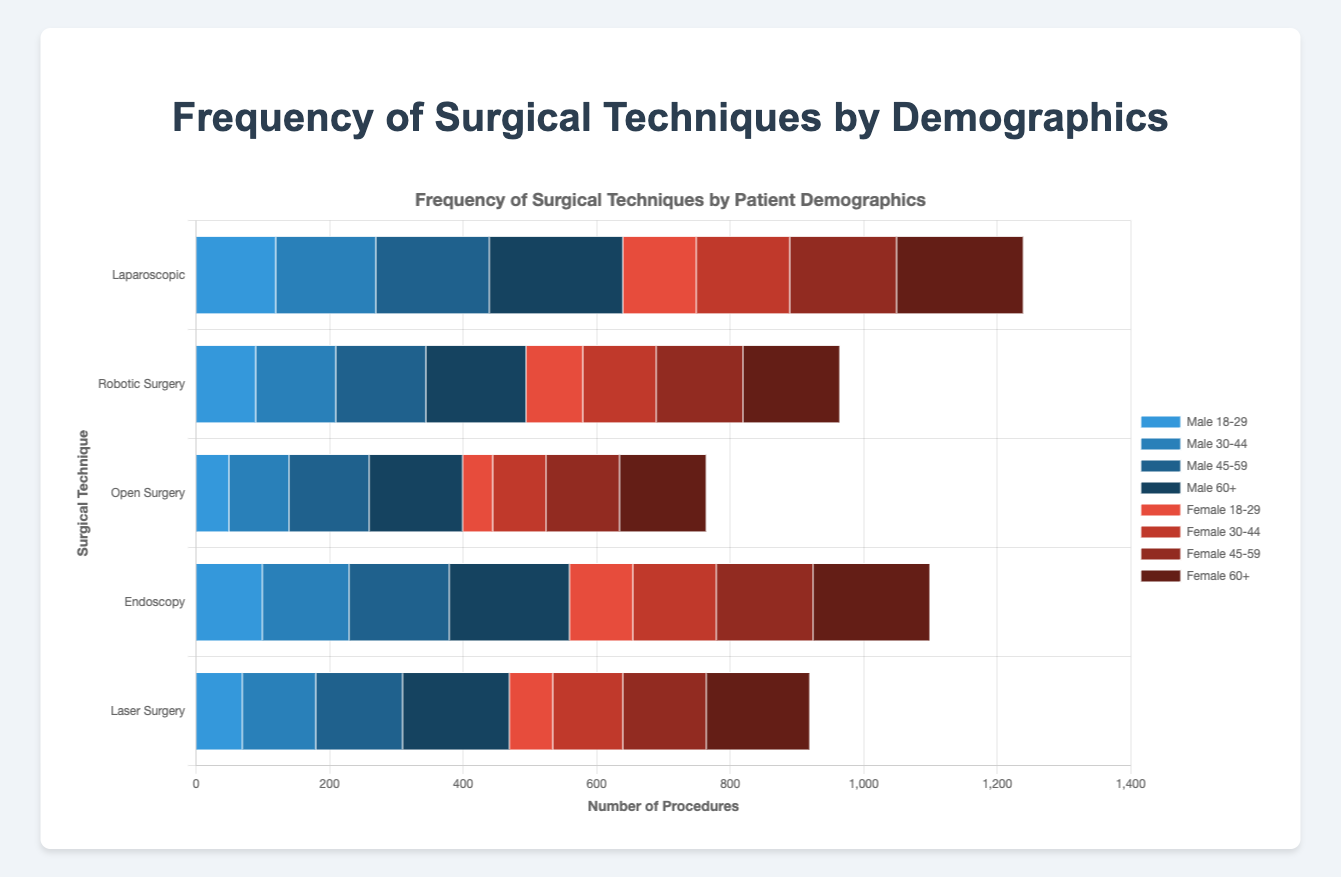Which technique is performed most frequently on males aged 60+? The longest bar for males aged 60+ corresponds to the "Laparoscopic" technique.
Answer: Laparoscopic Which age group of females has the highest frequency of Robotic Surgery? The longest bar for the female demographic within Robotic Surgery is for the age group 60+.
Answer: 60+ What is the total number of Endoscopy procedures performed on males of all age groups? Sum the frequencies of Endoscopy for males aged 18-29 (100), 30-44 (130), 45-59 (150), and 60+ (180): 100 + 130 + 150 + 180 = 560.
Answer: 560 How does the frequency of Laser Surgery for females aged 30-44 compare with that for males of the same age group? Compare the bar lengths for females (105) and males (110) in the 30-44 age group for Laser Surgery.
Answer: 105 vs. 110 What is the average number of Open Surgery procedures performed across all age groups for females? Sum the frequencies for females in Open Surgery: 45 (18-29) + 80 (30-44) + 110 (45-59) + 130 (60+) = 365. Divide by the number of age groups (4): 365 / 4 = 91.25.
Answer: 91.25 Which gender and age group has the least frequency for any technique, and what is the frequency? The shortest bar in the chart belongs to females aged 18-29 for Open Surgery, with a frequency of 45.
Answer: Females 18-29, 45 What is the difference in the frequency of Laparoscopic procedures between males aged 45-59 and females aged 45-59? Subtract the frequency for females (160) from males (170): 170 - 160 = 10.
Answer: 10 What is the combined total for Robotic Surgery and Laser Surgery procedures for males aged 30-44? Add the frequencies of Robotic Surgery (120) and Laser Surgery (110) for males aged 30-44: 120 + 110 = 230.
Answer: 230 Which technique sees the smallest difference in usage between males and females in the 60+ age group? Calculate the absolute difference for each technique for males and females in the 60+ age group: 
Laparoscopic (200-190=10), 
Robotic Surgery (150-145=5), 
Open Surgery (140-130=10), 
Endoscopy (180-175=5), 
Laser Surgery (160-155=5). 
The smallest difference is 5, observed in Robotic Surgery, Endoscopy, and Laser Surgery.
Answer: Robotic Surgery, Endoscopy, and Laser Surgery 